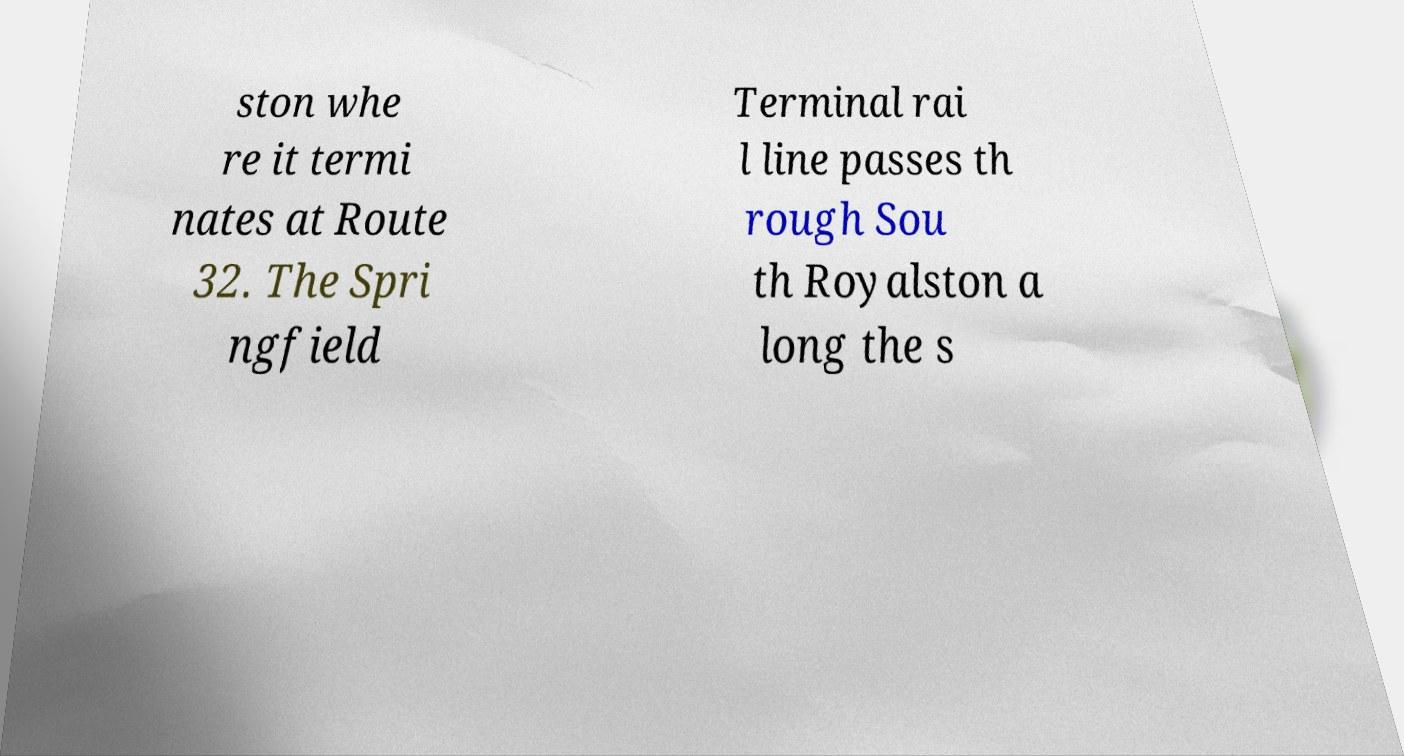For documentation purposes, I need the text within this image transcribed. Could you provide that? ston whe re it termi nates at Route 32. The Spri ngfield Terminal rai l line passes th rough Sou th Royalston a long the s 